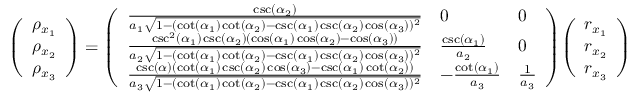<formula> <loc_0><loc_0><loc_500><loc_500>{ \left ( \begin{array} { l } { \rho _ { x _ { 1 } } } \\ { \rho _ { x _ { 2 } } } \\ { \rho _ { x _ { 3 } } } \end{array} \right ) } = { \left ( \begin{array} { l l l } { { \frac { \csc ( \alpha _ { 2 } ) } { a _ { 1 } { \sqrt { 1 - ( \cot ( \alpha _ { 1 } ) \cot ( \alpha _ { 2 } ) - \csc ( \alpha _ { 1 } ) \csc ( \alpha _ { 2 } ) \cos ( \alpha _ { 3 } ) ) ^ { 2 } } } } } } & { 0 } & { 0 } \\ { { \frac { \csc ^ { 2 } ( \alpha _ { 1 } ) \csc ( \alpha _ { 2 } ) ( \cos ( \alpha _ { 1 } ) \cos ( \alpha _ { 2 } ) - \cos ( \alpha _ { 3 } ) ) } { a _ { 2 } { \sqrt { 1 - ( \cot ( \alpha _ { 1 } ) \cot ( \alpha _ { 2 } ) - \csc ( \alpha _ { 1 } ) \csc ( \alpha _ { 2 } ) \cos ( \alpha _ { 3 } ) ) ^ { 2 } } } } } } & { { \frac { \csc ( \alpha _ { 1 } ) } { a _ { 2 } } } } & { 0 } \\ { { \frac { \csc ( \alpha ) ( \cot ( \alpha _ { 1 } ) \csc ( \alpha _ { 2 } ) \cos ( \alpha _ { 3 } ) - \csc ( \alpha _ { 1 } ) \cot ( \alpha _ { 2 } ) ) } { a _ { 3 } { \sqrt { 1 - ( \cot ( \alpha _ { 1 } ) \cot ( \alpha _ { 2 } ) - \csc ( \alpha _ { 1 } ) \csc ( \alpha _ { 2 } ) \cos ( \alpha _ { 3 } ) ) ^ { 2 } } } } } } & { - { \frac { \cot ( \alpha _ { 1 } ) } { a _ { 3 } } } } & { { \frac { 1 } { a _ { 3 } } } } \end{array} \right ) } { \left ( \begin{array} { l } { r _ { x _ { 1 } } } \\ { r _ { x _ { 2 } } } \\ { r _ { x _ { 3 } } } \end{array} \right ) }</formula> 